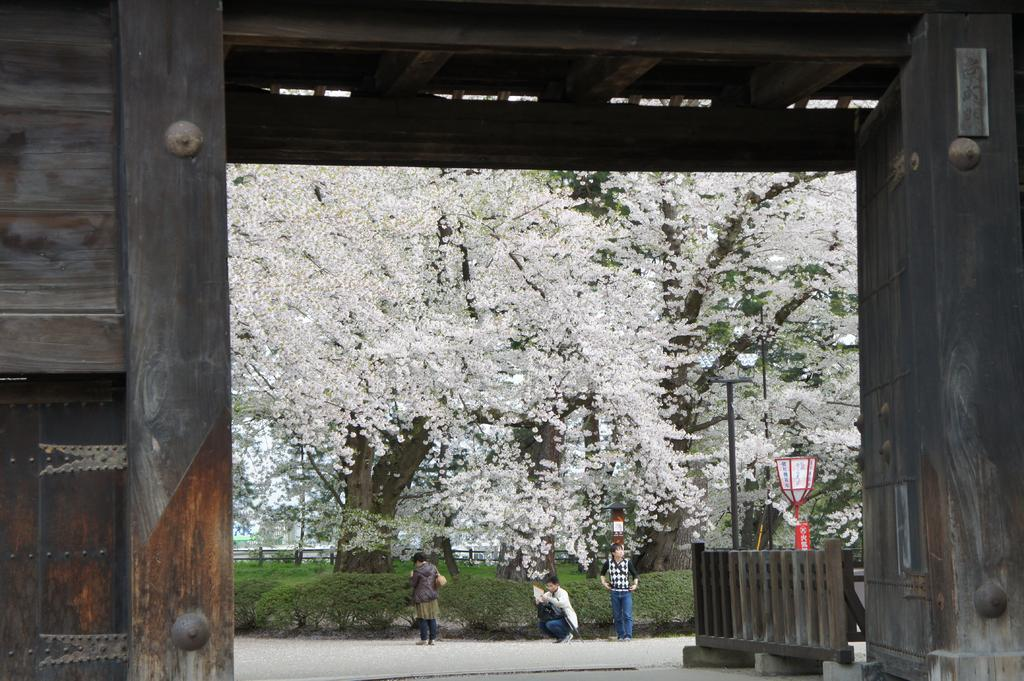What is located in the center of the image? There are trees in the center of the image. Can you describe the people in the image? There are persons in the image. What type of pathway is visible in the image? There is a road in the image. What type of vegetation is present in the image? There is grass in the image. What type of cheese can be seen hanging from the trees in the image? There is no cheese present in the image; it features trees, persons, a road, and grass. What type of trousers are the persons wearing in the image? The provided facts do not mention the type of trousers the persons are wearing, so we cannot determine that information from the image. 